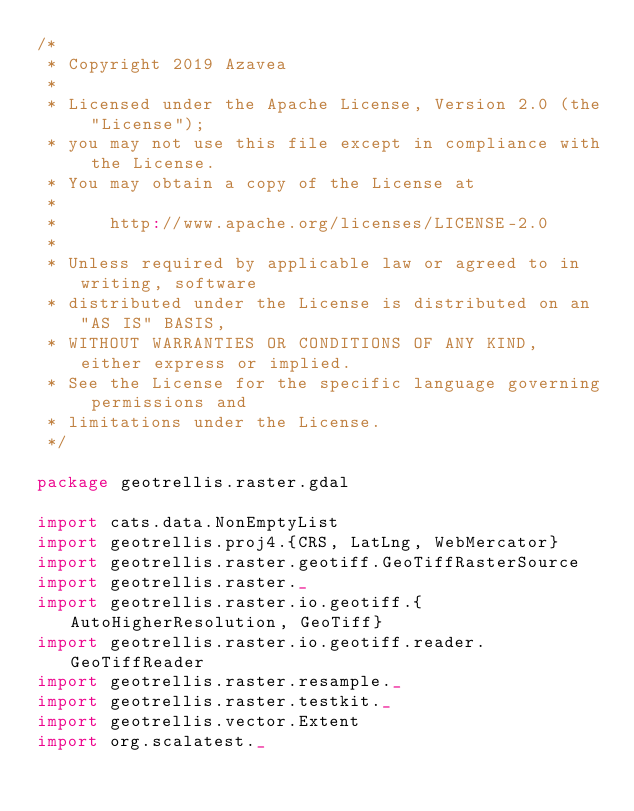<code> <loc_0><loc_0><loc_500><loc_500><_Scala_>/*
 * Copyright 2019 Azavea
 *
 * Licensed under the Apache License, Version 2.0 (the "License");
 * you may not use this file except in compliance with the License.
 * You may obtain a copy of the License at
 *
 *     http://www.apache.org/licenses/LICENSE-2.0
 *
 * Unless required by applicable law or agreed to in writing, software
 * distributed under the License is distributed on an "AS IS" BASIS,
 * WITHOUT WARRANTIES OR CONDITIONS OF ANY KIND, either express or implied.
 * See the License for the specific language governing permissions and
 * limitations under the License.
 */

package geotrellis.raster.gdal

import cats.data.NonEmptyList
import geotrellis.proj4.{CRS, LatLng, WebMercator}
import geotrellis.raster.geotiff.GeoTiffRasterSource
import geotrellis.raster._
import geotrellis.raster.io.geotiff.{AutoHigherResolution, GeoTiff}
import geotrellis.raster.io.geotiff.reader.GeoTiffReader
import geotrellis.raster.resample._
import geotrellis.raster.testkit._
import geotrellis.vector.Extent
import org.scalatest._
</code> 